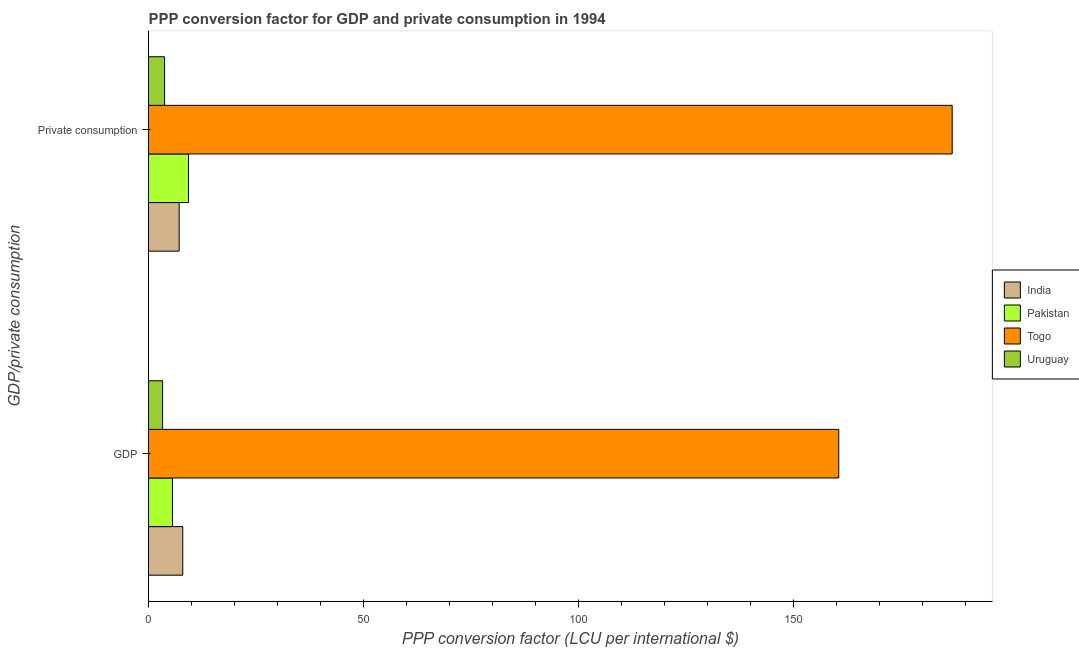How many different coloured bars are there?
Give a very brief answer. 4. What is the label of the 1st group of bars from the top?
Keep it short and to the point.  Private consumption. What is the ppp conversion factor for private consumption in Pakistan?
Make the answer very short. 9.3. Across all countries, what is the maximum ppp conversion factor for gdp?
Offer a terse response. 160.5. Across all countries, what is the minimum ppp conversion factor for private consumption?
Offer a very short reply. 3.74. In which country was the ppp conversion factor for private consumption maximum?
Offer a very short reply. Togo. In which country was the ppp conversion factor for gdp minimum?
Provide a succinct answer. Uruguay. What is the total ppp conversion factor for private consumption in the graph?
Your answer should be compact. 207.04. What is the difference between the ppp conversion factor for private consumption in Togo and that in India?
Your answer should be very brief. 179.75. What is the difference between the ppp conversion factor for gdp in Togo and the ppp conversion factor for private consumption in India?
Your response must be concise. 153.38. What is the average ppp conversion factor for private consumption per country?
Your answer should be very brief. 51.76. What is the difference between the ppp conversion factor for gdp and ppp conversion factor for private consumption in India?
Offer a very short reply. 0.84. What is the ratio of the ppp conversion factor for private consumption in Uruguay to that in Pakistan?
Ensure brevity in your answer.  0.4. In how many countries, is the ppp conversion factor for gdp greater than the average ppp conversion factor for gdp taken over all countries?
Offer a terse response. 1. What does the 2nd bar from the top in GDP represents?
Ensure brevity in your answer.  Togo. Are all the bars in the graph horizontal?
Provide a short and direct response. Yes. What is the difference between two consecutive major ticks on the X-axis?
Ensure brevity in your answer.  50. Are the values on the major ticks of X-axis written in scientific E-notation?
Provide a succinct answer. No. Where does the legend appear in the graph?
Your answer should be compact. Center right. How are the legend labels stacked?
Keep it short and to the point. Vertical. What is the title of the graph?
Provide a succinct answer. PPP conversion factor for GDP and private consumption in 1994. Does "Myanmar" appear as one of the legend labels in the graph?
Make the answer very short. No. What is the label or title of the X-axis?
Keep it short and to the point. PPP conversion factor (LCU per international $). What is the label or title of the Y-axis?
Offer a very short reply. GDP/private consumption. What is the PPP conversion factor (LCU per international $) in India in GDP?
Your answer should be compact. 7.96. What is the PPP conversion factor (LCU per international $) in Pakistan in GDP?
Your response must be concise. 5.56. What is the PPP conversion factor (LCU per international $) in Togo in GDP?
Offer a terse response. 160.5. What is the PPP conversion factor (LCU per international $) in Uruguay in GDP?
Keep it short and to the point. 3.28. What is the PPP conversion factor (LCU per international $) in India in  Private consumption?
Your response must be concise. 7.13. What is the PPP conversion factor (LCU per international $) of Pakistan in  Private consumption?
Make the answer very short. 9.3. What is the PPP conversion factor (LCU per international $) in Togo in  Private consumption?
Ensure brevity in your answer.  186.88. What is the PPP conversion factor (LCU per international $) of Uruguay in  Private consumption?
Offer a very short reply. 3.74. Across all GDP/private consumption, what is the maximum PPP conversion factor (LCU per international $) of India?
Provide a succinct answer. 7.96. Across all GDP/private consumption, what is the maximum PPP conversion factor (LCU per international $) of Pakistan?
Ensure brevity in your answer.  9.3. Across all GDP/private consumption, what is the maximum PPP conversion factor (LCU per international $) of Togo?
Your response must be concise. 186.88. Across all GDP/private consumption, what is the maximum PPP conversion factor (LCU per international $) of Uruguay?
Make the answer very short. 3.74. Across all GDP/private consumption, what is the minimum PPP conversion factor (LCU per international $) in India?
Provide a short and direct response. 7.13. Across all GDP/private consumption, what is the minimum PPP conversion factor (LCU per international $) of Pakistan?
Keep it short and to the point. 5.56. Across all GDP/private consumption, what is the minimum PPP conversion factor (LCU per international $) of Togo?
Your answer should be compact. 160.5. Across all GDP/private consumption, what is the minimum PPP conversion factor (LCU per international $) of Uruguay?
Make the answer very short. 3.28. What is the total PPP conversion factor (LCU per international $) in India in the graph?
Make the answer very short. 15.09. What is the total PPP conversion factor (LCU per international $) of Pakistan in the graph?
Ensure brevity in your answer.  14.87. What is the total PPP conversion factor (LCU per international $) in Togo in the graph?
Ensure brevity in your answer.  347.38. What is the total PPP conversion factor (LCU per international $) in Uruguay in the graph?
Make the answer very short. 7.01. What is the difference between the PPP conversion factor (LCU per international $) in India in GDP and that in  Private consumption?
Your response must be concise. 0.84. What is the difference between the PPP conversion factor (LCU per international $) of Pakistan in GDP and that in  Private consumption?
Your answer should be very brief. -3.74. What is the difference between the PPP conversion factor (LCU per international $) of Togo in GDP and that in  Private consumption?
Provide a short and direct response. -26.37. What is the difference between the PPP conversion factor (LCU per international $) of Uruguay in GDP and that in  Private consumption?
Make the answer very short. -0.46. What is the difference between the PPP conversion factor (LCU per international $) of India in GDP and the PPP conversion factor (LCU per international $) of Pakistan in  Private consumption?
Your answer should be compact. -1.34. What is the difference between the PPP conversion factor (LCU per international $) in India in GDP and the PPP conversion factor (LCU per international $) in Togo in  Private consumption?
Offer a terse response. -178.91. What is the difference between the PPP conversion factor (LCU per international $) of India in GDP and the PPP conversion factor (LCU per international $) of Uruguay in  Private consumption?
Provide a succinct answer. 4.23. What is the difference between the PPP conversion factor (LCU per international $) of Pakistan in GDP and the PPP conversion factor (LCU per international $) of Togo in  Private consumption?
Provide a succinct answer. -181.31. What is the difference between the PPP conversion factor (LCU per international $) of Pakistan in GDP and the PPP conversion factor (LCU per international $) of Uruguay in  Private consumption?
Make the answer very short. 1.83. What is the difference between the PPP conversion factor (LCU per international $) of Togo in GDP and the PPP conversion factor (LCU per international $) of Uruguay in  Private consumption?
Provide a short and direct response. 156.77. What is the average PPP conversion factor (LCU per international $) in India per GDP/private consumption?
Offer a terse response. 7.54. What is the average PPP conversion factor (LCU per international $) of Pakistan per GDP/private consumption?
Your answer should be very brief. 7.43. What is the average PPP conversion factor (LCU per international $) in Togo per GDP/private consumption?
Give a very brief answer. 173.69. What is the average PPP conversion factor (LCU per international $) of Uruguay per GDP/private consumption?
Offer a terse response. 3.51. What is the difference between the PPP conversion factor (LCU per international $) of India and PPP conversion factor (LCU per international $) of Pakistan in GDP?
Your answer should be very brief. 2.4. What is the difference between the PPP conversion factor (LCU per international $) in India and PPP conversion factor (LCU per international $) in Togo in GDP?
Provide a succinct answer. -152.54. What is the difference between the PPP conversion factor (LCU per international $) of India and PPP conversion factor (LCU per international $) of Uruguay in GDP?
Keep it short and to the point. 4.69. What is the difference between the PPP conversion factor (LCU per international $) in Pakistan and PPP conversion factor (LCU per international $) in Togo in GDP?
Ensure brevity in your answer.  -154.94. What is the difference between the PPP conversion factor (LCU per international $) in Pakistan and PPP conversion factor (LCU per international $) in Uruguay in GDP?
Ensure brevity in your answer.  2.29. What is the difference between the PPP conversion factor (LCU per international $) in Togo and PPP conversion factor (LCU per international $) in Uruguay in GDP?
Your answer should be very brief. 157.23. What is the difference between the PPP conversion factor (LCU per international $) of India and PPP conversion factor (LCU per international $) of Pakistan in  Private consumption?
Provide a succinct answer. -2.18. What is the difference between the PPP conversion factor (LCU per international $) of India and PPP conversion factor (LCU per international $) of Togo in  Private consumption?
Provide a short and direct response. -179.75. What is the difference between the PPP conversion factor (LCU per international $) in India and PPP conversion factor (LCU per international $) in Uruguay in  Private consumption?
Provide a short and direct response. 3.39. What is the difference between the PPP conversion factor (LCU per international $) in Pakistan and PPP conversion factor (LCU per international $) in Togo in  Private consumption?
Make the answer very short. -177.57. What is the difference between the PPP conversion factor (LCU per international $) of Pakistan and PPP conversion factor (LCU per international $) of Uruguay in  Private consumption?
Give a very brief answer. 5.57. What is the difference between the PPP conversion factor (LCU per international $) of Togo and PPP conversion factor (LCU per international $) of Uruguay in  Private consumption?
Ensure brevity in your answer.  183.14. What is the ratio of the PPP conversion factor (LCU per international $) in India in GDP to that in  Private consumption?
Your answer should be very brief. 1.12. What is the ratio of the PPP conversion factor (LCU per international $) in Pakistan in GDP to that in  Private consumption?
Your response must be concise. 0.6. What is the ratio of the PPP conversion factor (LCU per international $) in Togo in GDP to that in  Private consumption?
Provide a short and direct response. 0.86. What is the ratio of the PPP conversion factor (LCU per international $) in Uruguay in GDP to that in  Private consumption?
Your response must be concise. 0.88. What is the difference between the highest and the second highest PPP conversion factor (LCU per international $) in India?
Offer a terse response. 0.84. What is the difference between the highest and the second highest PPP conversion factor (LCU per international $) in Pakistan?
Your response must be concise. 3.74. What is the difference between the highest and the second highest PPP conversion factor (LCU per international $) in Togo?
Keep it short and to the point. 26.37. What is the difference between the highest and the second highest PPP conversion factor (LCU per international $) in Uruguay?
Make the answer very short. 0.46. What is the difference between the highest and the lowest PPP conversion factor (LCU per international $) in India?
Offer a very short reply. 0.84. What is the difference between the highest and the lowest PPP conversion factor (LCU per international $) in Pakistan?
Offer a terse response. 3.74. What is the difference between the highest and the lowest PPP conversion factor (LCU per international $) of Togo?
Give a very brief answer. 26.37. What is the difference between the highest and the lowest PPP conversion factor (LCU per international $) in Uruguay?
Your response must be concise. 0.46. 